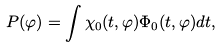Convert formula to latex. <formula><loc_0><loc_0><loc_500><loc_500>P ( \varphi ) = \int \chi _ { 0 } ( { t } , \varphi ) \Phi _ { 0 } ( { t } , \varphi ) d { t } ,</formula> 